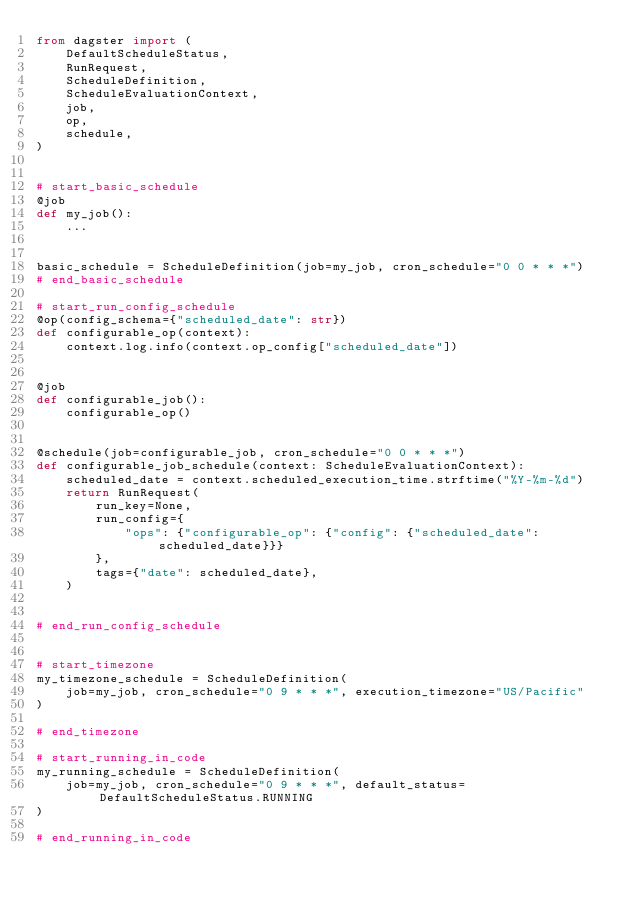<code> <loc_0><loc_0><loc_500><loc_500><_Python_>from dagster import (
    DefaultScheduleStatus,
    RunRequest,
    ScheduleDefinition,
    ScheduleEvaluationContext,
    job,
    op,
    schedule,
)


# start_basic_schedule
@job
def my_job():
    ...


basic_schedule = ScheduleDefinition(job=my_job, cron_schedule="0 0 * * *")
# end_basic_schedule

# start_run_config_schedule
@op(config_schema={"scheduled_date": str})
def configurable_op(context):
    context.log.info(context.op_config["scheduled_date"])


@job
def configurable_job():
    configurable_op()


@schedule(job=configurable_job, cron_schedule="0 0 * * *")
def configurable_job_schedule(context: ScheduleEvaluationContext):
    scheduled_date = context.scheduled_execution_time.strftime("%Y-%m-%d")
    return RunRequest(
        run_key=None,
        run_config={
            "ops": {"configurable_op": {"config": {"scheduled_date": scheduled_date}}}
        },
        tags={"date": scheduled_date},
    )


# end_run_config_schedule


# start_timezone
my_timezone_schedule = ScheduleDefinition(
    job=my_job, cron_schedule="0 9 * * *", execution_timezone="US/Pacific"
)

# end_timezone

# start_running_in_code
my_running_schedule = ScheduleDefinition(
    job=my_job, cron_schedule="0 9 * * *", default_status=DefaultScheduleStatus.RUNNING
)

# end_running_in_code
</code> 